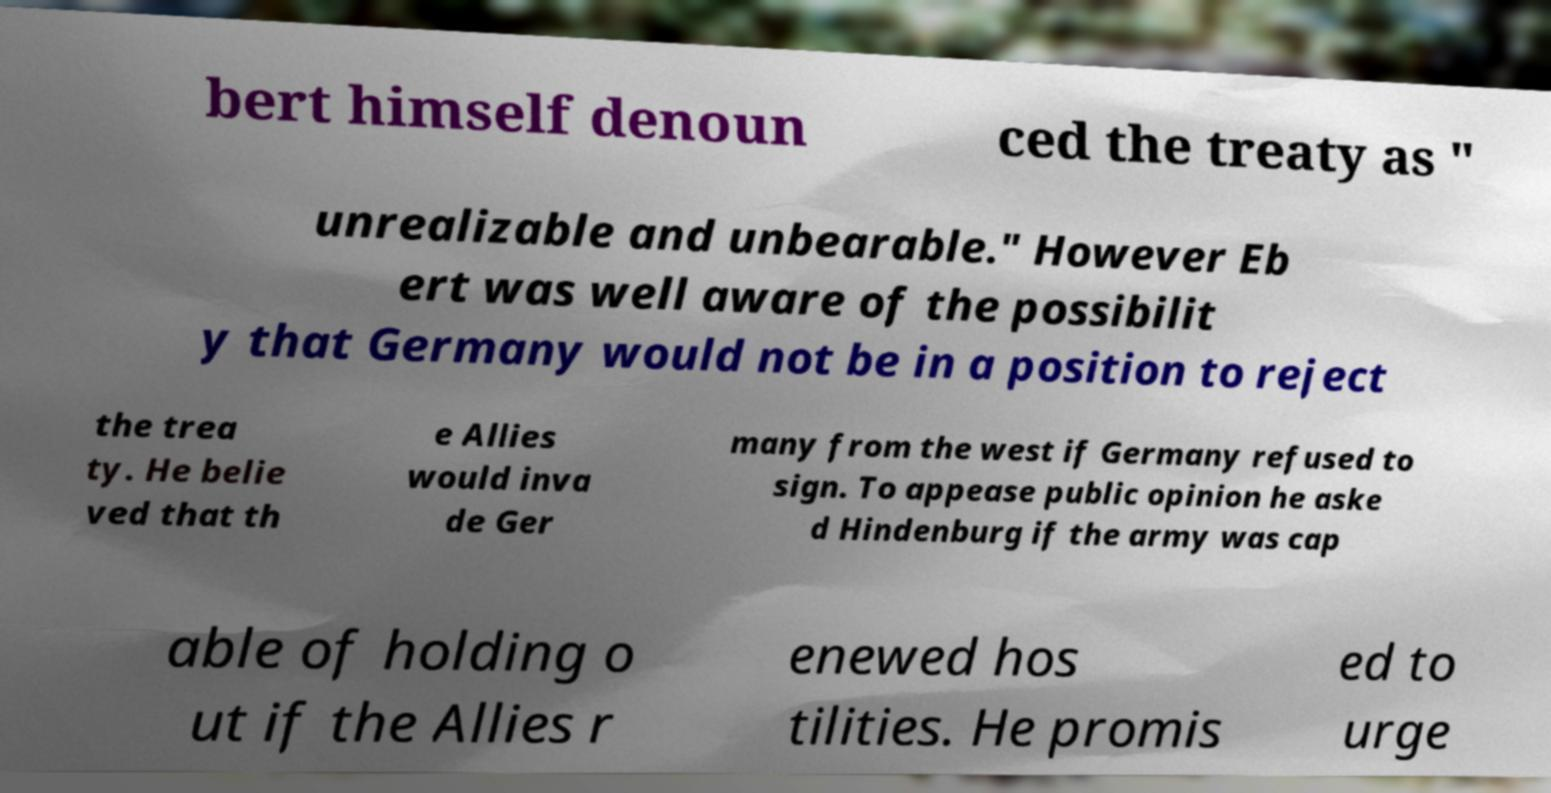Please identify and transcribe the text found in this image. bert himself denoun ced the treaty as " unrealizable and unbearable." However Eb ert was well aware of the possibilit y that Germany would not be in a position to reject the trea ty. He belie ved that th e Allies would inva de Ger many from the west if Germany refused to sign. To appease public opinion he aske d Hindenburg if the army was cap able of holding o ut if the Allies r enewed hos tilities. He promis ed to urge 